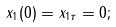<formula> <loc_0><loc_0><loc_500><loc_500>x _ { 1 } ( 0 ) = x _ { 1 \tau } = 0 ;</formula> 